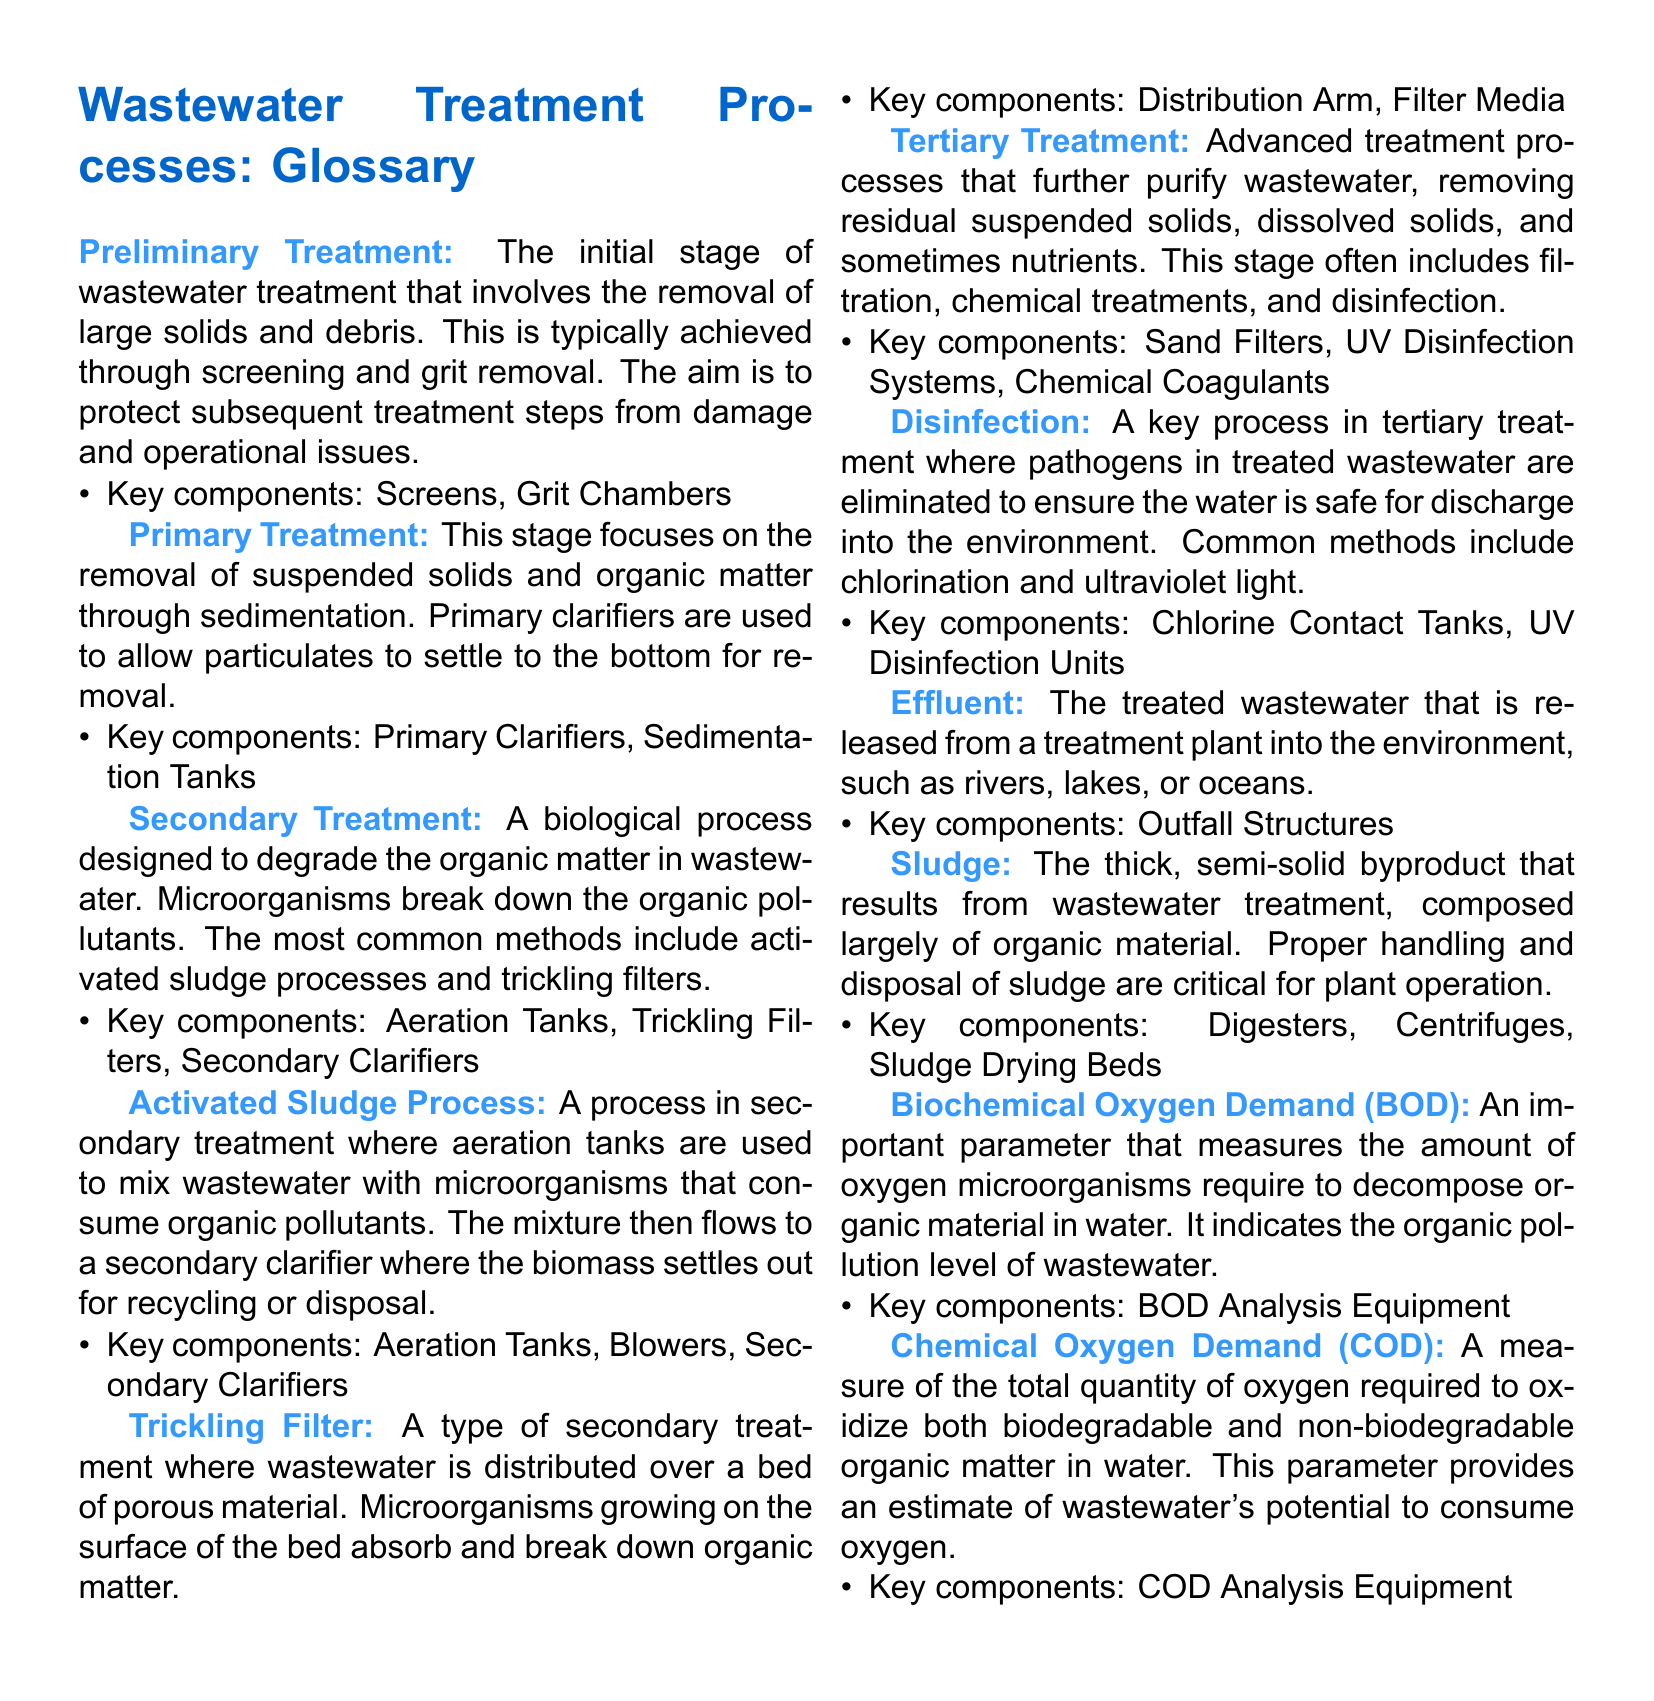What is the purpose of preliminary treatment? Preliminary treatment involves the removal of large solids and debris to protect subsequent treatment steps.
Answer: Removal of large solids and debris What are key components of secondary treatment? Secondary treatment focuses on the biological degradation of organic matter, using components like aeration tanks and trickling filters.
Answer: Aeration Tanks, Trickling Filters, Secondary Clarifiers What process uses aeration tanks to mix wastewater? The activated sludge process utilizes aeration tanks to mix wastewater with microorganisms for organic pollutant degradation.
Answer: Activated Sludge Process What are common methods of disinfection in tertiary treatment? Common methods of disinfection include chlorination and ultraviolet light to eliminate pathogens in treated wastewater.
Answer: Chlorination and ultraviolet light What type of treatment follows primary treatment? Secondary treatment follows primary treatment and focuses on the biological breakdown of organic matter.
Answer: Secondary treatment What does BOD measure? BOD measures the amount of oxygen microorganisms require to decompose organic material in water, indicating organic pollution levels.
Answer: Amount of oxygen required for decomposition What is the byproduct of wastewater treatment? The thick, semi-solid byproduct that results from treatment is known as sludge, which must be properly handled.
Answer: Sludge What is the final treated wastewater called? The treated wastewater released from a treatment plant is referred to as effluent.
Answer: Effluent What advanced treatment processes aim to purify wastewater further? Tertiary treatment processes are advanced methods that further purify wastewater by removing residual materials.
Answer: Tertiary treatment processes 